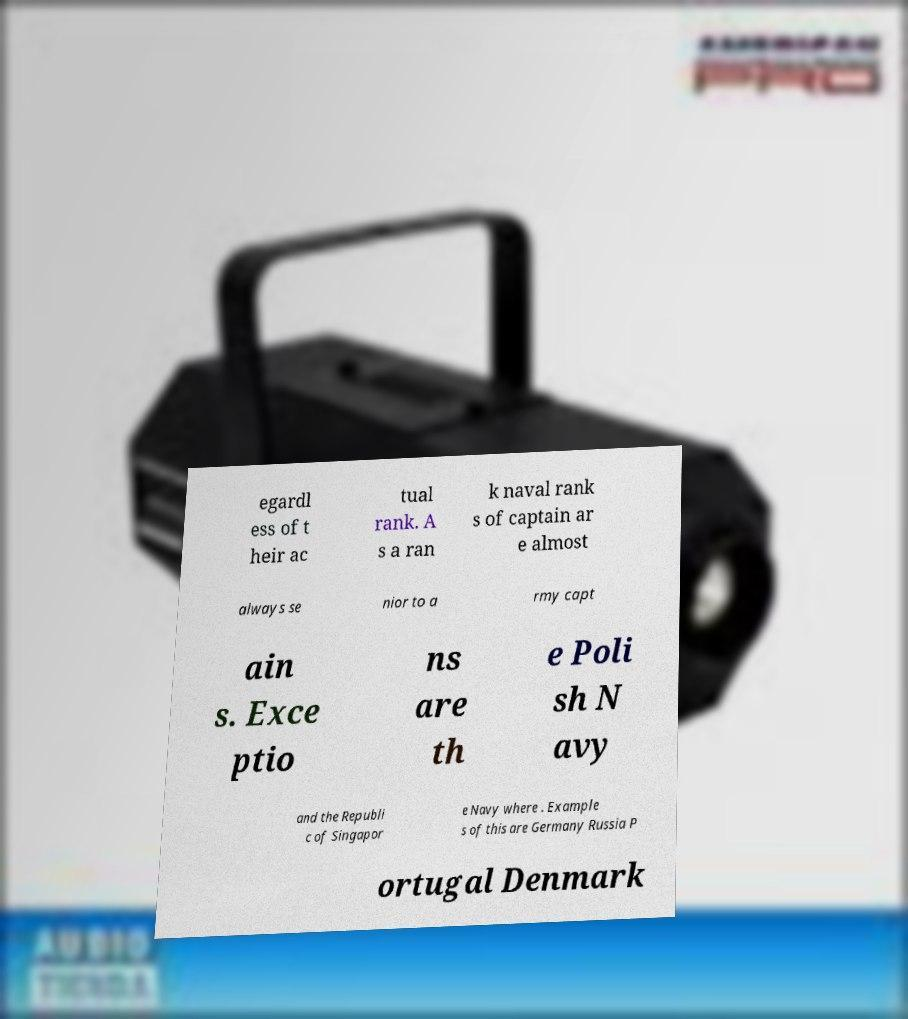For documentation purposes, I need the text within this image transcribed. Could you provide that? egardl ess of t heir ac tual rank. A s a ran k naval rank s of captain ar e almost always se nior to a rmy capt ain s. Exce ptio ns are th e Poli sh N avy and the Republi c of Singapor e Navy where . Example s of this are Germany Russia P ortugal Denmark 